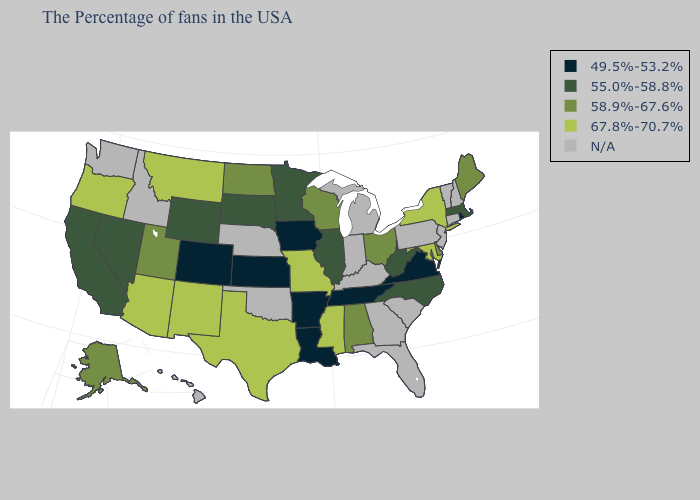Name the states that have a value in the range 55.0%-58.8%?
Answer briefly. Massachusetts, North Carolina, West Virginia, Illinois, Minnesota, South Dakota, Wyoming, Nevada, California. What is the lowest value in the MidWest?
Short answer required. 49.5%-53.2%. Which states have the lowest value in the USA?
Give a very brief answer. Rhode Island, Virginia, Tennessee, Louisiana, Arkansas, Iowa, Kansas, Colorado. What is the lowest value in the USA?
Concise answer only. 49.5%-53.2%. Does Alabama have the highest value in the USA?
Answer briefly. No. Which states hav the highest value in the Northeast?
Answer briefly. New York. Does Maryland have the highest value in the USA?
Quick response, please. Yes. Name the states that have a value in the range N/A?
Quick response, please. New Hampshire, Vermont, Connecticut, New Jersey, Pennsylvania, South Carolina, Florida, Georgia, Michigan, Kentucky, Indiana, Nebraska, Oklahoma, Idaho, Washington, Hawaii. Does the map have missing data?
Answer briefly. Yes. Which states have the highest value in the USA?
Give a very brief answer. New York, Maryland, Mississippi, Missouri, Texas, New Mexico, Montana, Arizona, Oregon. What is the value of Washington?
Be succinct. N/A. Name the states that have a value in the range N/A?
Keep it brief. New Hampshire, Vermont, Connecticut, New Jersey, Pennsylvania, South Carolina, Florida, Georgia, Michigan, Kentucky, Indiana, Nebraska, Oklahoma, Idaho, Washington, Hawaii. What is the value of Rhode Island?
Concise answer only. 49.5%-53.2%. Is the legend a continuous bar?
Give a very brief answer. No. Is the legend a continuous bar?
Quick response, please. No. 